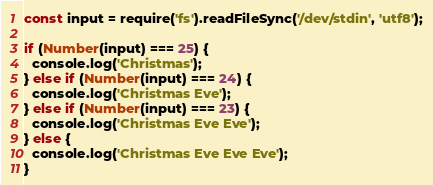Convert code to text. <code><loc_0><loc_0><loc_500><loc_500><_JavaScript_>const input = require('fs').readFileSync('/dev/stdin', 'utf8');
 
if (Number(input) === 25) {
  console.log('Christmas');
} else if (Number(input) === 24) {
  console.log('Christmas Eve');
} else if (Number(input) === 23) {
  console.log('Christmas Eve Eve');
} else {
  console.log('Christmas Eve Eve Eve');
}</code> 